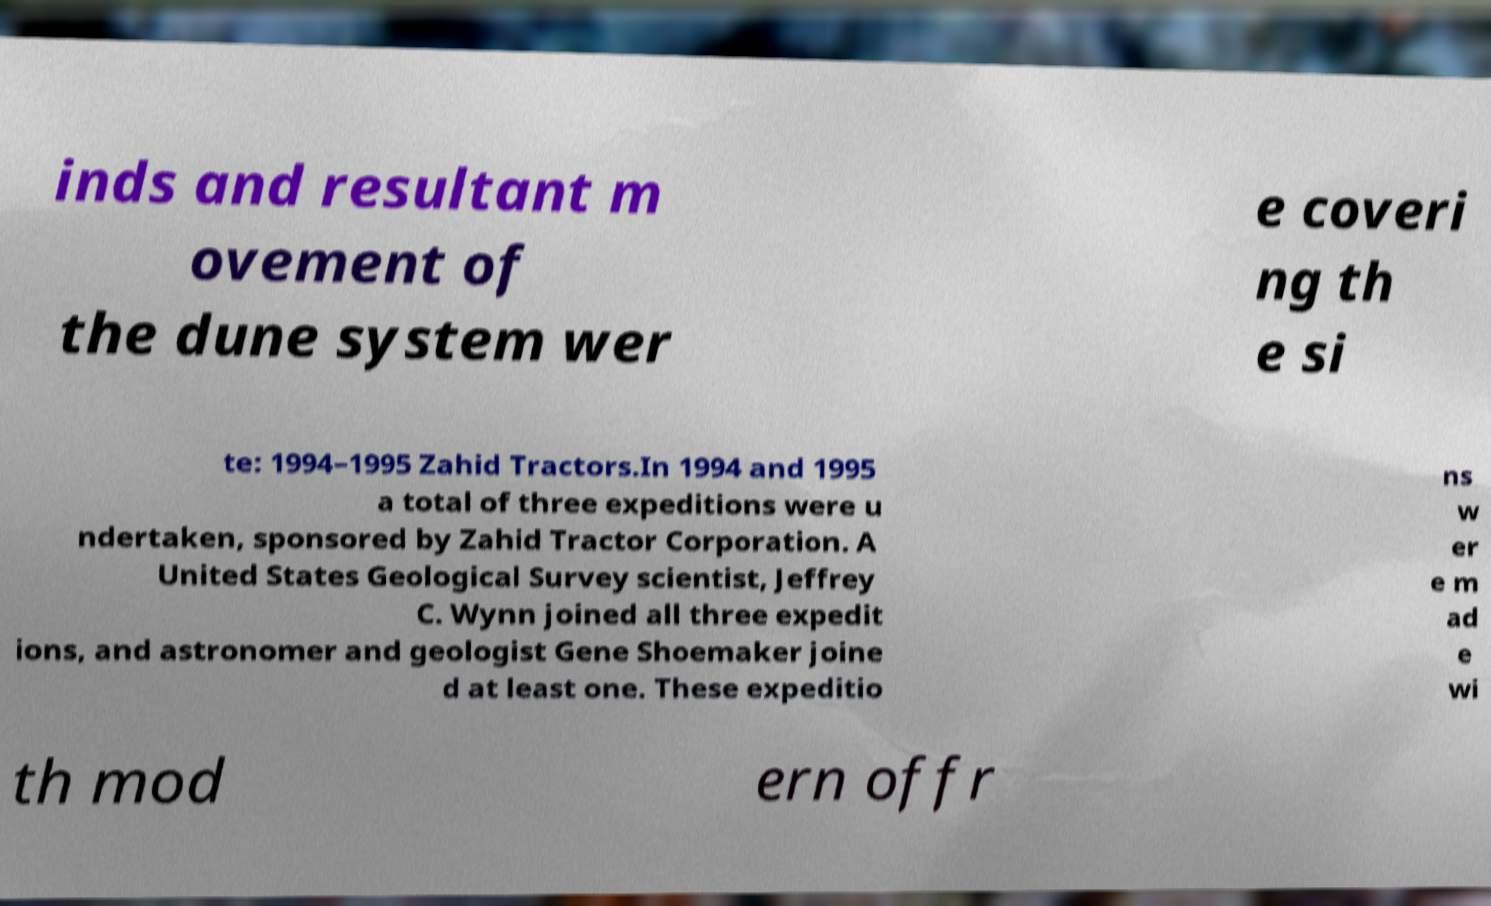Can you read and provide the text displayed in the image?This photo seems to have some interesting text. Can you extract and type it out for me? inds and resultant m ovement of the dune system wer e coveri ng th e si te: 1994–1995 Zahid Tractors.In 1994 and 1995 a total of three expeditions were u ndertaken, sponsored by Zahid Tractor Corporation. A United States Geological Survey scientist, Jeffrey C. Wynn joined all three expedit ions, and astronomer and geologist Gene Shoemaker joine d at least one. These expeditio ns w er e m ad e wi th mod ern offr 